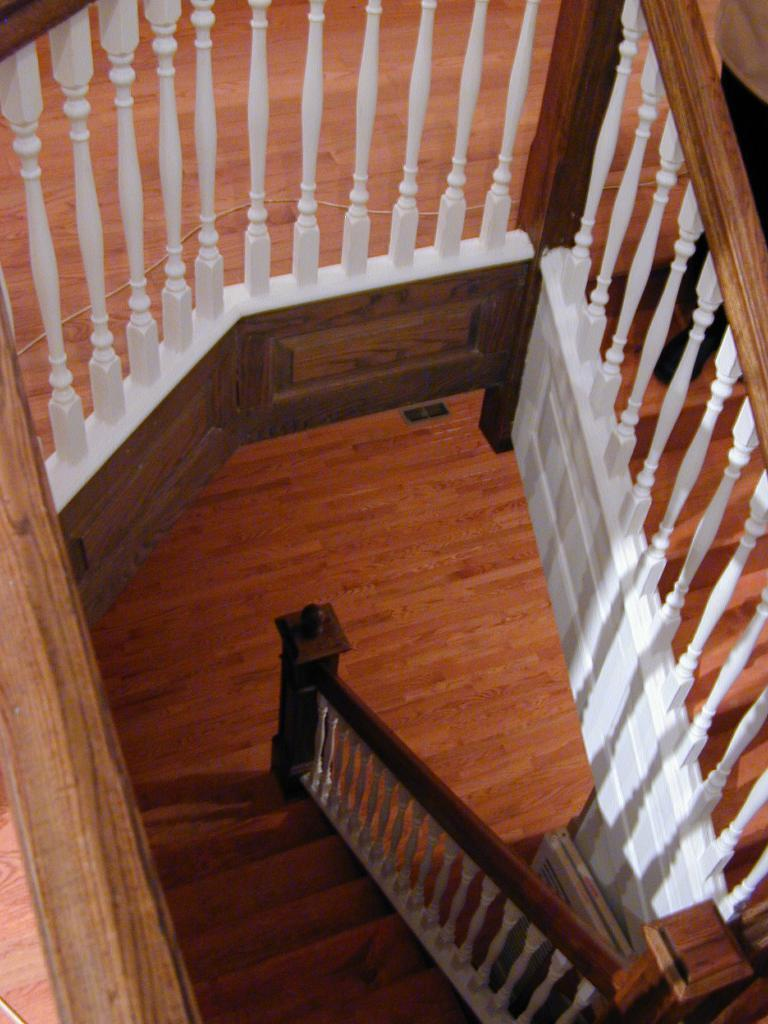What type of flooring is visible in the image? There is a wooden floor in the image. What architectural feature can be seen in the image? There are stairs in the image. What is the purpose of the barrier in the image? There is a fence in the image, which serves as a barrier. What object is used for tying or securing in the image? There is a rope in the image. Who is present in the image? There is a person in the image. What is the person wearing? The person is wearing clothes. What type of thunder can be heard in the image? There is no thunder present in the image, as it is a visual medium and does not contain sound. 